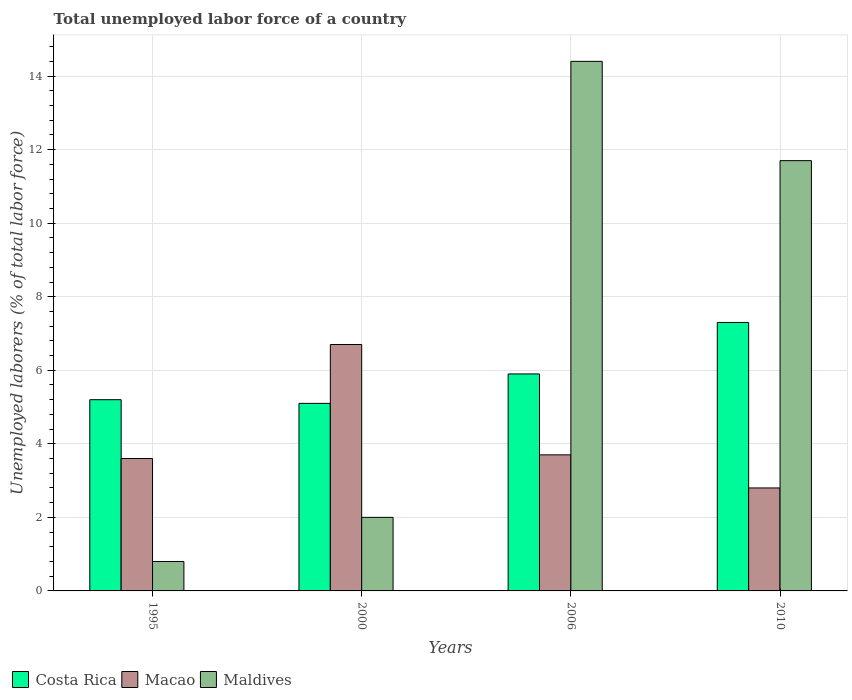Are the number of bars per tick equal to the number of legend labels?
Your response must be concise. Yes. How many bars are there on the 4th tick from the right?
Offer a terse response. 3. In how many cases, is the number of bars for a given year not equal to the number of legend labels?
Offer a terse response. 0. What is the total unemployed labor force in Maldives in 1995?
Ensure brevity in your answer.  0.8. Across all years, what is the maximum total unemployed labor force in Costa Rica?
Provide a short and direct response. 7.3. Across all years, what is the minimum total unemployed labor force in Costa Rica?
Your response must be concise. 5.1. In which year was the total unemployed labor force in Maldives minimum?
Provide a short and direct response. 1995. What is the total total unemployed labor force in Costa Rica in the graph?
Offer a very short reply. 23.5. What is the difference between the total unemployed labor force in Costa Rica in 1995 and that in 2006?
Your answer should be very brief. -0.7. What is the difference between the total unemployed labor force in Maldives in 2010 and the total unemployed labor force in Costa Rica in 2006?
Make the answer very short. 5.8. What is the average total unemployed labor force in Costa Rica per year?
Keep it short and to the point. 5.87. In the year 1995, what is the difference between the total unemployed labor force in Maldives and total unemployed labor force in Macao?
Your response must be concise. -2.8. In how many years, is the total unemployed labor force in Maldives greater than 8.4 %?
Your answer should be compact. 2. What is the ratio of the total unemployed labor force in Maldives in 1995 to that in 2006?
Ensure brevity in your answer.  0.06. Is the total unemployed labor force in Costa Rica in 2006 less than that in 2010?
Provide a succinct answer. Yes. What is the difference between the highest and the second highest total unemployed labor force in Maldives?
Ensure brevity in your answer.  2.7. What is the difference between the highest and the lowest total unemployed labor force in Costa Rica?
Provide a succinct answer. 2.2. In how many years, is the total unemployed labor force in Maldives greater than the average total unemployed labor force in Maldives taken over all years?
Your answer should be very brief. 2. What does the 3rd bar from the left in 1995 represents?
Offer a very short reply. Maldives. What does the 2nd bar from the right in 2000 represents?
Your answer should be very brief. Macao. Is it the case that in every year, the sum of the total unemployed labor force in Costa Rica and total unemployed labor force in Macao is greater than the total unemployed labor force in Maldives?
Provide a short and direct response. No. How many bars are there?
Offer a very short reply. 12. How many years are there in the graph?
Give a very brief answer. 4. Does the graph contain any zero values?
Make the answer very short. No. Does the graph contain grids?
Your answer should be compact. Yes. Where does the legend appear in the graph?
Make the answer very short. Bottom left. What is the title of the graph?
Offer a very short reply. Total unemployed labor force of a country. What is the label or title of the X-axis?
Your answer should be very brief. Years. What is the label or title of the Y-axis?
Ensure brevity in your answer.  Unemployed laborers (% of total labor force). What is the Unemployed laborers (% of total labor force) in Costa Rica in 1995?
Keep it short and to the point. 5.2. What is the Unemployed laborers (% of total labor force) of Macao in 1995?
Give a very brief answer. 3.6. What is the Unemployed laborers (% of total labor force) in Maldives in 1995?
Your answer should be very brief. 0.8. What is the Unemployed laborers (% of total labor force) of Costa Rica in 2000?
Your answer should be very brief. 5.1. What is the Unemployed laborers (% of total labor force) of Macao in 2000?
Make the answer very short. 6.7. What is the Unemployed laborers (% of total labor force) of Maldives in 2000?
Your answer should be compact. 2. What is the Unemployed laborers (% of total labor force) in Costa Rica in 2006?
Offer a very short reply. 5.9. What is the Unemployed laborers (% of total labor force) of Macao in 2006?
Offer a terse response. 3.7. What is the Unemployed laborers (% of total labor force) in Maldives in 2006?
Provide a short and direct response. 14.4. What is the Unemployed laborers (% of total labor force) of Costa Rica in 2010?
Offer a very short reply. 7.3. What is the Unemployed laborers (% of total labor force) in Macao in 2010?
Ensure brevity in your answer.  2.8. What is the Unemployed laborers (% of total labor force) in Maldives in 2010?
Offer a very short reply. 11.7. Across all years, what is the maximum Unemployed laborers (% of total labor force) in Costa Rica?
Ensure brevity in your answer.  7.3. Across all years, what is the maximum Unemployed laborers (% of total labor force) of Macao?
Offer a terse response. 6.7. Across all years, what is the maximum Unemployed laborers (% of total labor force) in Maldives?
Make the answer very short. 14.4. Across all years, what is the minimum Unemployed laborers (% of total labor force) of Costa Rica?
Offer a very short reply. 5.1. Across all years, what is the minimum Unemployed laborers (% of total labor force) in Macao?
Keep it short and to the point. 2.8. Across all years, what is the minimum Unemployed laborers (% of total labor force) of Maldives?
Provide a succinct answer. 0.8. What is the total Unemployed laborers (% of total labor force) of Costa Rica in the graph?
Offer a terse response. 23.5. What is the total Unemployed laborers (% of total labor force) of Maldives in the graph?
Provide a short and direct response. 28.9. What is the difference between the Unemployed laborers (% of total labor force) of Costa Rica in 1995 and that in 2000?
Offer a terse response. 0.1. What is the difference between the Unemployed laborers (% of total labor force) of Costa Rica in 1995 and that in 2006?
Ensure brevity in your answer.  -0.7. What is the difference between the Unemployed laborers (% of total labor force) in Macao in 1995 and that in 2006?
Your answer should be compact. -0.1. What is the difference between the Unemployed laborers (% of total labor force) in Maldives in 1995 and that in 2006?
Make the answer very short. -13.6. What is the difference between the Unemployed laborers (% of total labor force) of Macao in 1995 and that in 2010?
Offer a terse response. 0.8. What is the difference between the Unemployed laborers (% of total labor force) of Costa Rica in 2000 and that in 2006?
Keep it short and to the point. -0.8. What is the difference between the Unemployed laborers (% of total labor force) in Maldives in 2000 and that in 2006?
Keep it short and to the point. -12.4. What is the difference between the Unemployed laborers (% of total labor force) of Costa Rica in 2000 and that in 2010?
Give a very brief answer. -2.2. What is the difference between the Unemployed laborers (% of total labor force) of Macao in 1995 and the Unemployed laborers (% of total labor force) of Maldives in 2006?
Keep it short and to the point. -10.8. What is the difference between the Unemployed laborers (% of total labor force) in Costa Rica in 1995 and the Unemployed laborers (% of total labor force) in Maldives in 2010?
Offer a very short reply. -6.5. What is the difference between the Unemployed laborers (% of total labor force) in Costa Rica in 2000 and the Unemployed laborers (% of total labor force) in Macao in 2006?
Your answer should be compact. 1.4. What is the difference between the Unemployed laborers (% of total labor force) of Macao in 2000 and the Unemployed laborers (% of total labor force) of Maldives in 2006?
Your answer should be very brief. -7.7. What is the difference between the Unemployed laborers (% of total labor force) of Costa Rica in 2000 and the Unemployed laborers (% of total labor force) of Macao in 2010?
Offer a terse response. 2.3. What is the difference between the Unemployed laborers (% of total labor force) of Costa Rica in 2000 and the Unemployed laborers (% of total labor force) of Maldives in 2010?
Give a very brief answer. -6.6. What is the difference between the Unemployed laborers (% of total labor force) in Costa Rica in 2006 and the Unemployed laborers (% of total labor force) in Maldives in 2010?
Provide a short and direct response. -5.8. What is the average Unemployed laborers (% of total labor force) of Costa Rica per year?
Your response must be concise. 5.88. What is the average Unemployed laborers (% of total labor force) in Macao per year?
Offer a very short reply. 4.2. What is the average Unemployed laborers (% of total labor force) of Maldives per year?
Offer a terse response. 7.22. In the year 1995, what is the difference between the Unemployed laborers (% of total labor force) of Costa Rica and Unemployed laborers (% of total labor force) of Macao?
Ensure brevity in your answer.  1.6. In the year 1995, what is the difference between the Unemployed laborers (% of total labor force) of Macao and Unemployed laborers (% of total labor force) of Maldives?
Provide a short and direct response. 2.8. In the year 2000, what is the difference between the Unemployed laborers (% of total labor force) of Costa Rica and Unemployed laborers (% of total labor force) of Maldives?
Offer a terse response. 3.1. In the year 2006, what is the difference between the Unemployed laborers (% of total labor force) in Costa Rica and Unemployed laborers (% of total labor force) in Macao?
Give a very brief answer. 2.2. In the year 2006, what is the difference between the Unemployed laborers (% of total labor force) in Macao and Unemployed laborers (% of total labor force) in Maldives?
Make the answer very short. -10.7. In the year 2010, what is the difference between the Unemployed laborers (% of total labor force) of Costa Rica and Unemployed laborers (% of total labor force) of Macao?
Provide a short and direct response. 4.5. In the year 2010, what is the difference between the Unemployed laborers (% of total labor force) in Macao and Unemployed laborers (% of total labor force) in Maldives?
Offer a terse response. -8.9. What is the ratio of the Unemployed laborers (% of total labor force) of Costa Rica in 1995 to that in 2000?
Ensure brevity in your answer.  1.02. What is the ratio of the Unemployed laborers (% of total labor force) of Macao in 1995 to that in 2000?
Provide a succinct answer. 0.54. What is the ratio of the Unemployed laborers (% of total labor force) in Maldives in 1995 to that in 2000?
Keep it short and to the point. 0.4. What is the ratio of the Unemployed laborers (% of total labor force) of Costa Rica in 1995 to that in 2006?
Your response must be concise. 0.88. What is the ratio of the Unemployed laborers (% of total labor force) in Maldives in 1995 to that in 2006?
Offer a terse response. 0.06. What is the ratio of the Unemployed laborers (% of total labor force) in Costa Rica in 1995 to that in 2010?
Provide a short and direct response. 0.71. What is the ratio of the Unemployed laborers (% of total labor force) of Macao in 1995 to that in 2010?
Give a very brief answer. 1.29. What is the ratio of the Unemployed laborers (% of total labor force) in Maldives in 1995 to that in 2010?
Ensure brevity in your answer.  0.07. What is the ratio of the Unemployed laborers (% of total labor force) in Costa Rica in 2000 to that in 2006?
Your response must be concise. 0.86. What is the ratio of the Unemployed laborers (% of total labor force) in Macao in 2000 to that in 2006?
Offer a very short reply. 1.81. What is the ratio of the Unemployed laborers (% of total labor force) of Maldives in 2000 to that in 2006?
Offer a very short reply. 0.14. What is the ratio of the Unemployed laborers (% of total labor force) of Costa Rica in 2000 to that in 2010?
Keep it short and to the point. 0.7. What is the ratio of the Unemployed laborers (% of total labor force) in Macao in 2000 to that in 2010?
Your response must be concise. 2.39. What is the ratio of the Unemployed laborers (% of total labor force) of Maldives in 2000 to that in 2010?
Provide a succinct answer. 0.17. What is the ratio of the Unemployed laborers (% of total labor force) in Costa Rica in 2006 to that in 2010?
Keep it short and to the point. 0.81. What is the ratio of the Unemployed laborers (% of total labor force) in Macao in 2006 to that in 2010?
Your answer should be compact. 1.32. What is the ratio of the Unemployed laborers (% of total labor force) of Maldives in 2006 to that in 2010?
Offer a very short reply. 1.23. What is the difference between the highest and the second highest Unemployed laborers (% of total labor force) of Costa Rica?
Provide a short and direct response. 1.4. What is the difference between the highest and the lowest Unemployed laborers (% of total labor force) in Costa Rica?
Provide a succinct answer. 2.2. What is the difference between the highest and the lowest Unemployed laborers (% of total labor force) in Macao?
Provide a succinct answer. 3.9. What is the difference between the highest and the lowest Unemployed laborers (% of total labor force) in Maldives?
Provide a short and direct response. 13.6. 